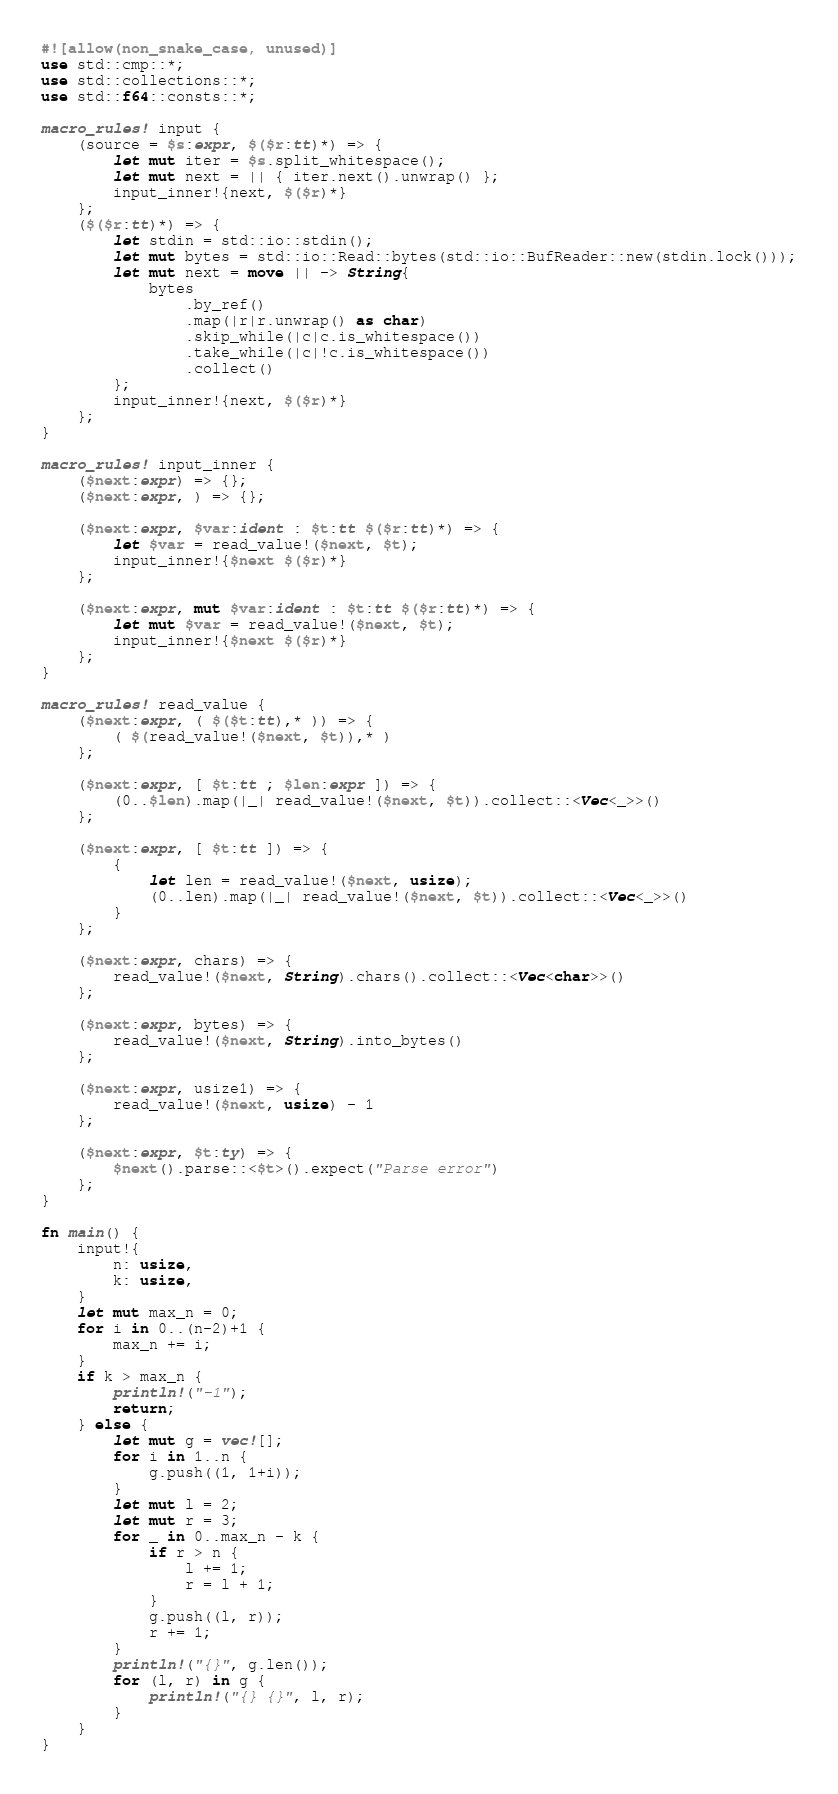Convert code to text. <code><loc_0><loc_0><loc_500><loc_500><_Rust_>#![allow(non_snake_case, unused)]
use std::cmp::*;
use std::collections::*;
use std::f64::consts::*;

macro_rules! input {
    (source = $s:expr, $($r:tt)*) => {
        let mut iter = $s.split_whitespace();
        let mut next = || { iter.next().unwrap() };
        input_inner!{next, $($r)*}
    };
    ($($r:tt)*) => {
        let stdin = std::io::stdin();
        let mut bytes = std::io::Read::bytes(std::io::BufReader::new(stdin.lock()));
        let mut next = move || -> String{
            bytes
                .by_ref()
                .map(|r|r.unwrap() as char)
                .skip_while(|c|c.is_whitespace())
                .take_while(|c|!c.is_whitespace())
                .collect()
        };
        input_inner!{next, $($r)*}
    };
}

macro_rules! input_inner {
    ($next:expr) => {};
    ($next:expr, ) => {};

    ($next:expr, $var:ident : $t:tt $($r:tt)*) => {
        let $var = read_value!($next, $t);
        input_inner!{$next $($r)*}
    };

    ($next:expr, mut $var:ident : $t:tt $($r:tt)*) => {
        let mut $var = read_value!($next, $t);
        input_inner!{$next $($r)*}
    };
}

macro_rules! read_value {
    ($next:expr, ( $($t:tt),* )) => {
        ( $(read_value!($next, $t)),* )
    };

    ($next:expr, [ $t:tt ; $len:expr ]) => {
        (0..$len).map(|_| read_value!($next, $t)).collect::<Vec<_>>()
    };

    ($next:expr, [ $t:tt ]) => {
        {
            let len = read_value!($next, usize);
            (0..len).map(|_| read_value!($next, $t)).collect::<Vec<_>>()
        }
    };

    ($next:expr, chars) => {
        read_value!($next, String).chars().collect::<Vec<char>>()
    };

    ($next:expr, bytes) => {
        read_value!($next, String).into_bytes()
    };

    ($next:expr, usize1) => {
        read_value!($next, usize) - 1
    };

    ($next:expr, $t:ty) => {
        $next().parse::<$t>().expect("Parse error")
    };
}

fn main() {
    input!{
        n: usize,
        k: usize,
    }
    let mut max_n = 0;
    for i in 0..(n-2)+1 {
        max_n += i;
    }
    if k > max_n {
        println!("-1");
        return;
    } else {
        let mut g = vec![];
        for i in 1..n {
            g.push((1, 1+i));
        }
        let mut l = 2;
        let mut r = 3;
        for _ in 0..max_n - k {
            if r > n {
                l += 1;
                r = l + 1;
            }
            g.push((l, r));
            r += 1;
        }
        println!("{}", g.len());
        for (l, r) in g {
            println!("{} {}", l, r);
        }
    }
}
</code> 